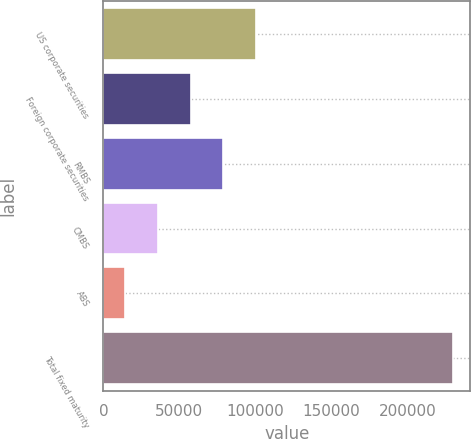<chart> <loc_0><loc_0><loc_500><loc_500><bar_chart><fcel>US corporate securities<fcel>Foreign corporate securities<fcel>RMBS<fcel>CMBS<fcel>ABS<fcel>Total fixed maturity<nl><fcel>100447<fcel>57359.4<fcel>78903.1<fcel>35815.7<fcel>14272<fcel>229709<nl></chart> 